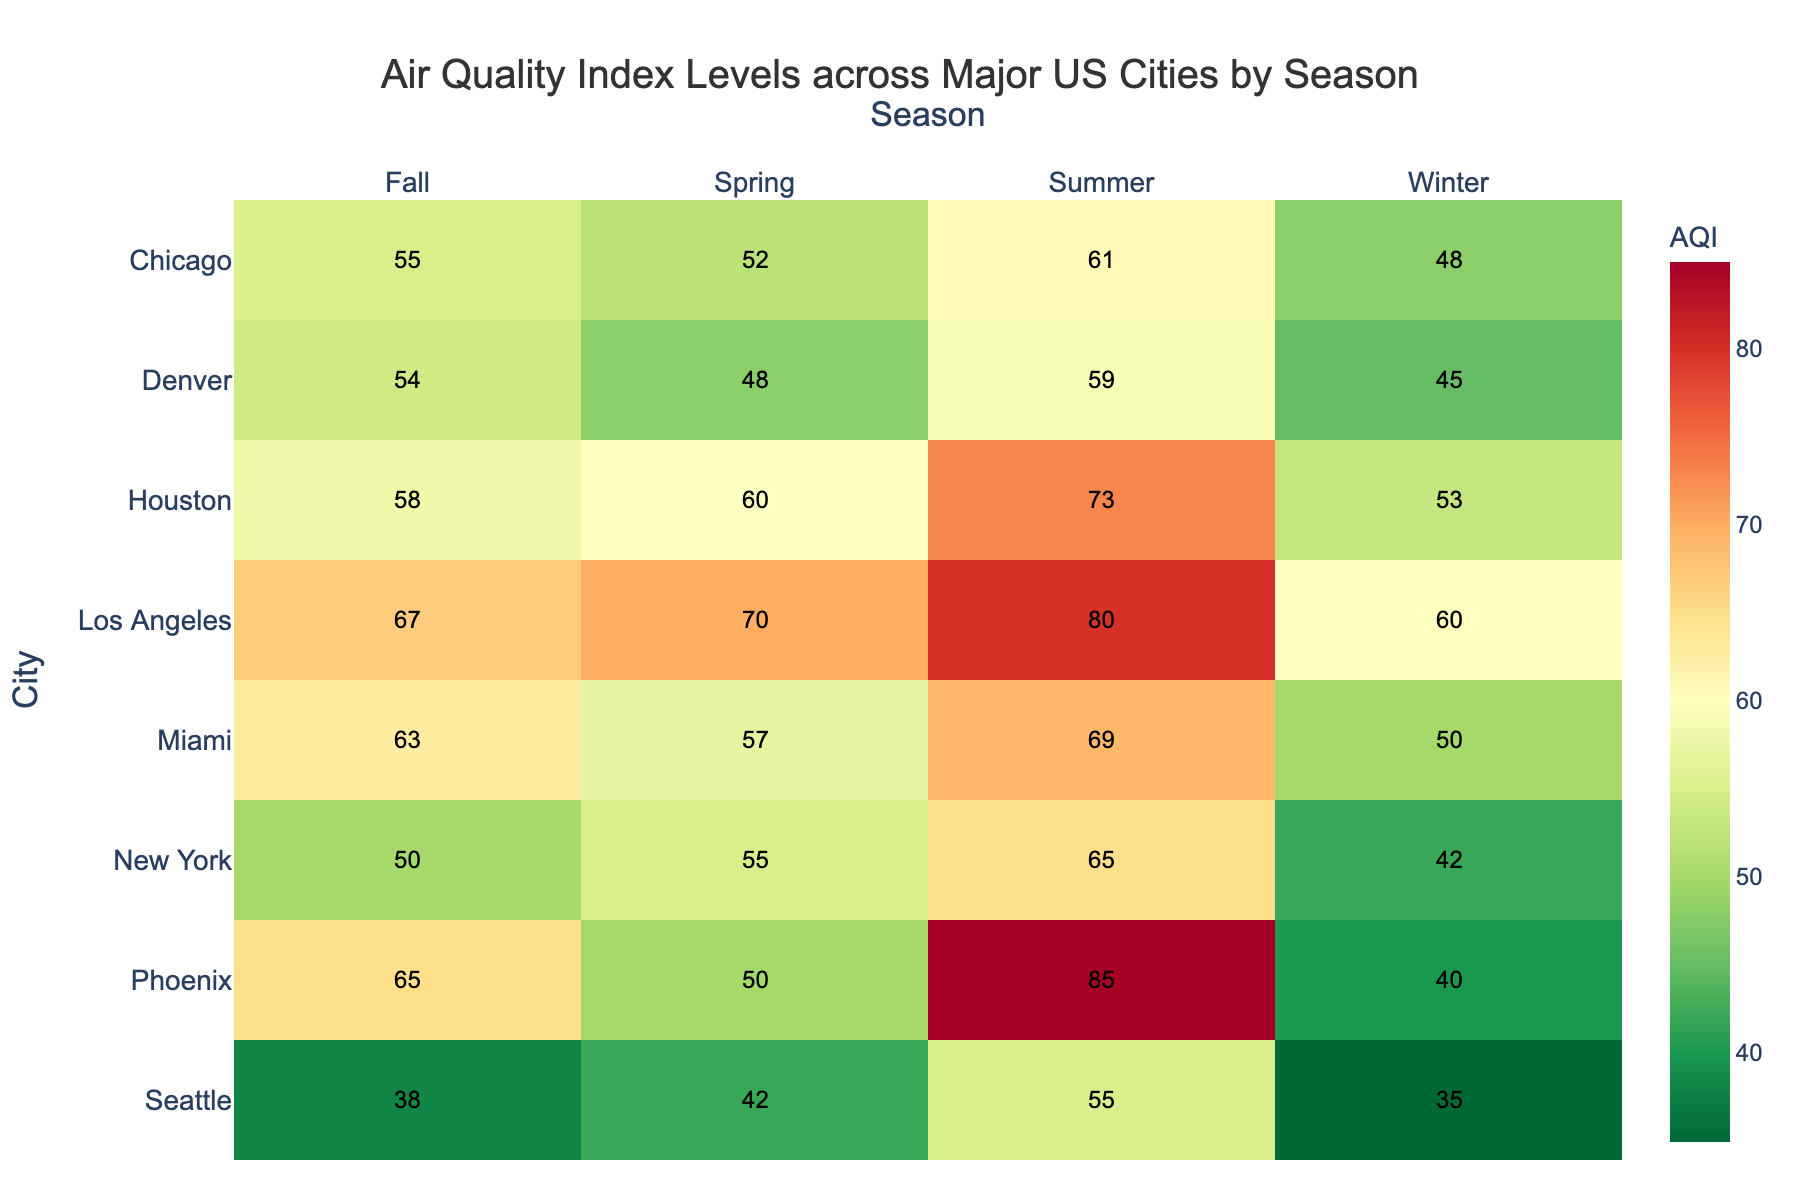What is the title of the heatmap? The title is written at the top and labeled as such: "Air Quality Index Levels across Major US Cities by Season"
Answer: Air Quality Index Levels across Major US Cities by Season Which city has the highest Air Quality Index (AQI) during summer? By checking the summer column and comparing all the visible values, the highest number is 85 for Phoenix.
Answer: Phoenix What is the average AQI value for Los Angeles? To find the average, sum the AQI values for Los Angeles over all seasons (60 + 70 + 80 + 67 = 277) and then divide by the number of seasons (4). So, 277 / 4 = 69.25
Answer: 69.25 Which season generally has the highest AQI levels across all cities? By comparing the AQI values column by column, summer consistently shows higher values across multiple cities.
Answer: Summer What is the difference in AQI between New York in summer and winter? Identify the AQI for New York in summer (65) and in winter (42). Subtract the winter value from the summer value: 65 - 42 = 23
Answer: 23 Which city has the lowest AQI during winter? Check the winter column and pick the lowest visible value, which is 35 for Seattle.
Answer: Seattle How does the AQI in Miami during fall compare to Houston in fall? Look at the AQI values for both cities in fall: Miami (63) and Houston (58). Miami's AQI is higher.
Answer: Miami's AQI is higher What's the sum of AQI values for Chicago across all seasons? Add the AQI values for Chicago: 48 (Winter) + 52 (Spring) + 61 (Summer) + 55 (Fall) = 216
Answer: 216 Which season shows the least variation in AQI values across all cities? Observe the range within each season column. Winter varies from 35 to 60 (25 units), Spring varies from 42 to 70 (28 units), Summer varies from 55 to 85 (30 units), and Fall varies from 38 to 67 (29 units). The winter season has the least variation.
Answer: Winter What is the median AQI value for the cities in spring? List the AQI values for spring (55, 70, 52, 60, 50, 48, 42, 57). Ordering them (42, 48, 50, 52, 55, 57, 60, 70) gives a median at the average of 52 and 55. So, (52 + 55) / 2 = 53.5
Answer: 53.5 